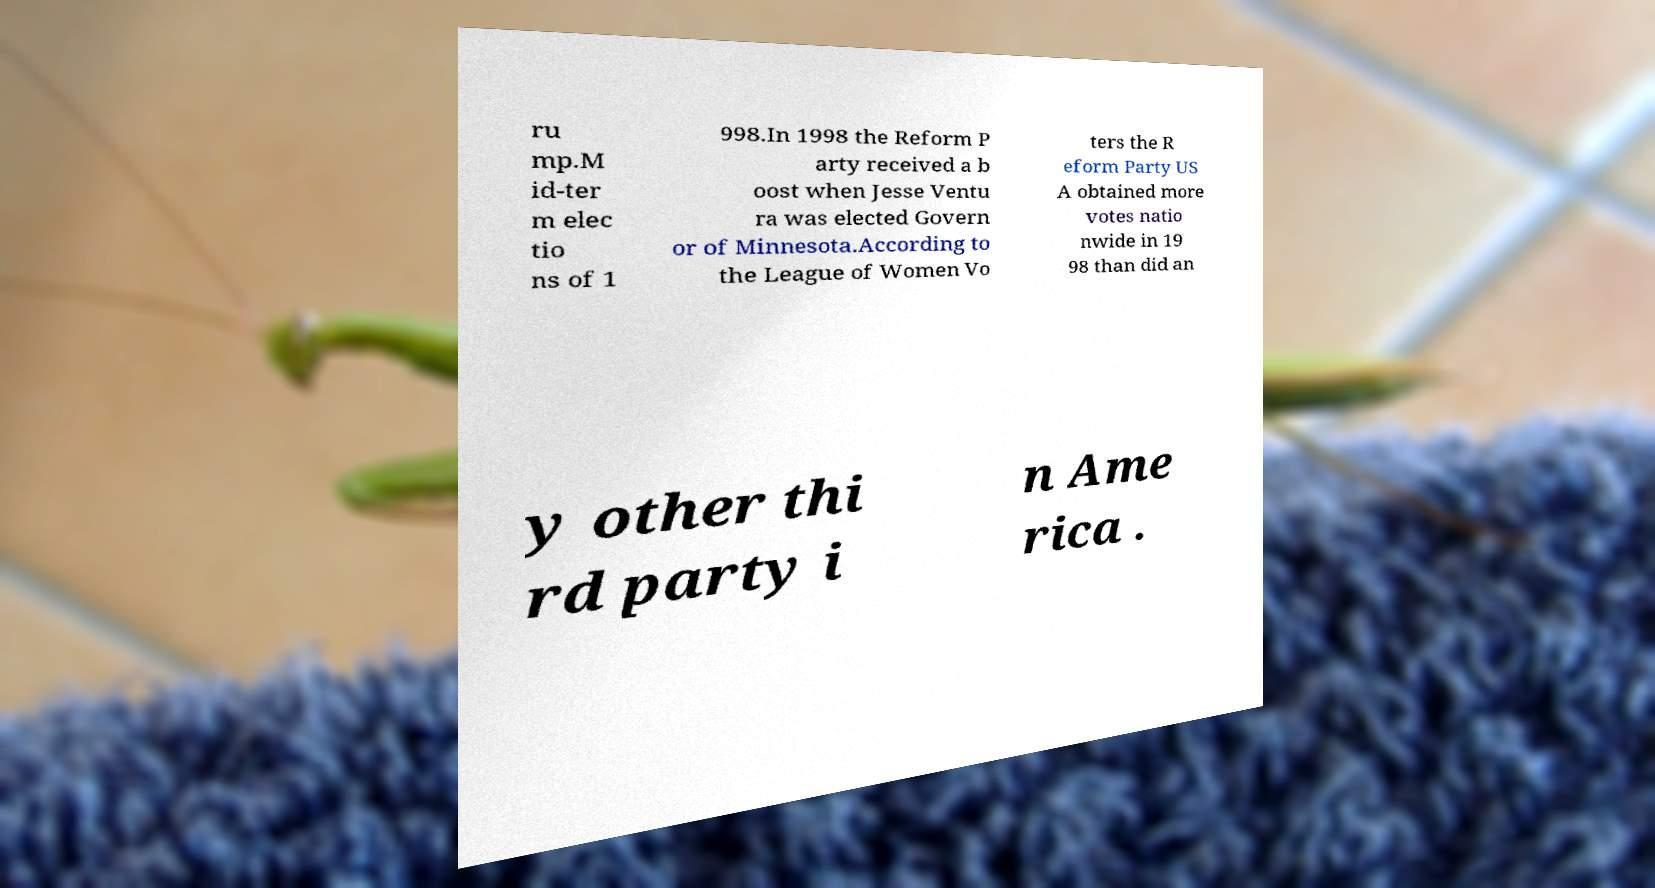Could you assist in decoding the text presented in this image and type it out clearly? ru mp.M id-ter m elec tio ns of 1 998.In 1998 the Reform P arty received a b oost when Jesse Ventu ra was elected Govern or of Minnesota.According to the League of Women Vo ters the R eform Party US A obtained more votes natio nwide in 19 98 than did an y other thi rd party i n Ame rica . 